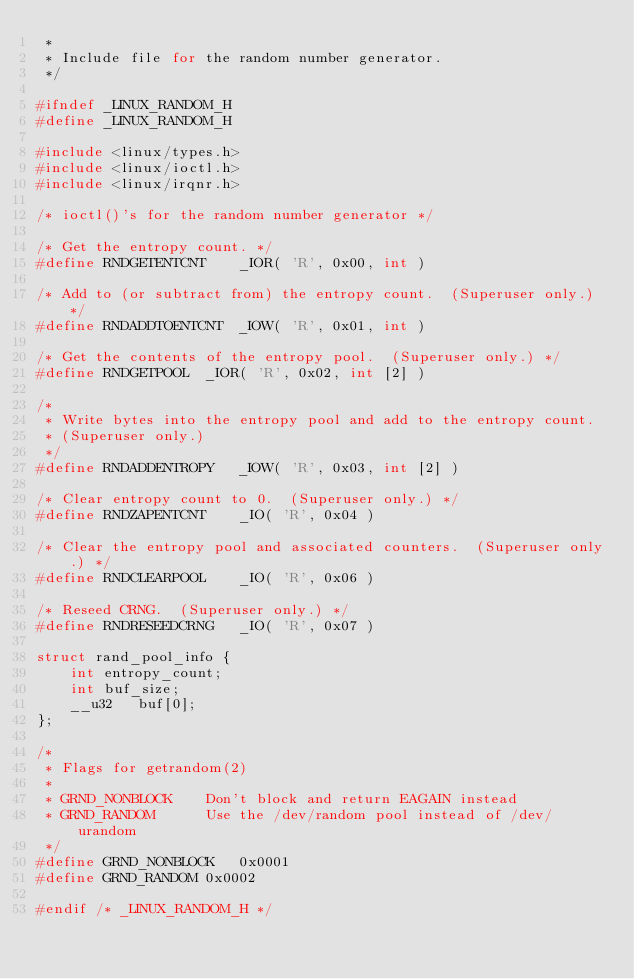Convert code to text. <code><loc_0><loc_0><loc_500><loc_500><_C_> *
 * Include file for the random number generator.
 */

#ifndef _LINUX_RANDOM_H
#define _LINUX_RANDOM_H

#include <linux/types.h>
#include <linux/ioctl.h>
#include <linux/irqnr.h>

/* ioctl()'s for the random number generator */

/* Get the entropy count. */
#define RNDGETENTCNT	_IOR( 'R', 0x00, int )

/* Add to (or subtract from) the entropy count.  (Superuser only.) */
#define RNDADDTOENTCNT	_IOW( 'R', 0x01, int )

/* Get the contents of the entropy pool.  (Superuser only.) */
#define RNDGETPOOL	_IOR( 'R', 0x02, int [2] )

/* 
 * Write bytes into the entropy pool and add to the entropy count.
 * (Superuser only.)
 */
#define RNDADDENTROPY	_IOW( 'R', 0x03, int [2] )

/* Clear entropy count to 0.  (Superuser only.) */
#define RNDZAPENTCNT	_IO( 'R', 0x04 )

/* Clear the entropy pool and associated counters.  (Superuser only.) */
#define RNDCLEARPOOL	_IO( 'R', 0x06 )

/* Reseed CRNG.  (Superuser only.) */
#define RNDRESEEDCRNG	_IO( 'R', 0x07 )

struct rand_pool_info {
	int	entropy_count;
	int	buf_size;
	__u32	buf[0];
};

/*
 * Flags for getrandom(2)
 *
 * GRND_NONBLOCK	Don't block and return EAGAIN instead
 * GRND_RANDOM		Use the /dev/random pool instead of /dev/urandom
 */
#define GRND_NONBLOCK	0x0001
#define GRND_RANDOM	0x0002

#endif /* _LINUX_RANDOM_H */</code> 